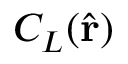Convert formula to latex. <formula><loc_0><loc_0><loc_500><loc_500>C _ { L } ( \hat { r } )</formula> 